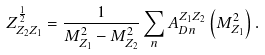<formula> <loc_0><loc_0><loc_500><loc_500>Z ^ { \frac { 1 } { 2 } } _ { Z _ { 2 } Z _ { 1 } } = \frac { 1 } { M ^ { 2 } _ { Z _ { 1 } } - M ^ { 2 } _ { Z _ { 2 } } } \sum _ { n } A _ { D n } ^ { Z _ { 1 } Z _ { 2 } } \left ( M ^ { 2 } _ { Z _ { 1 } } \right ) .</formula> 